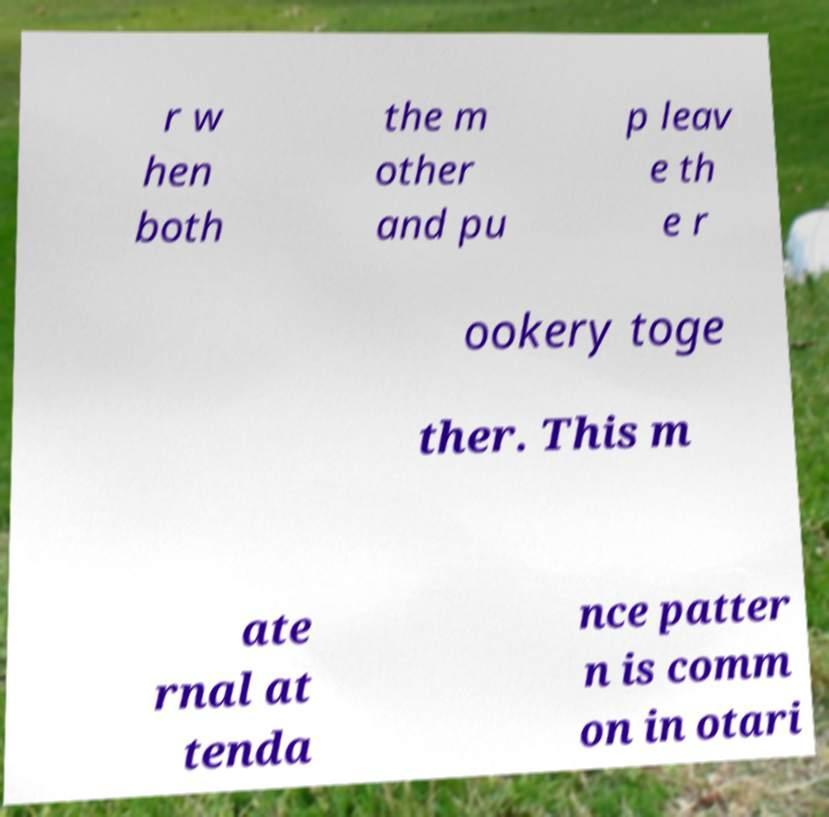Could you extract and type out the text from this image? r w hen both the m other and pu p leav e th e r ookery toge ther. This m ate rnal at tenda nce patter n is comm on in otari 